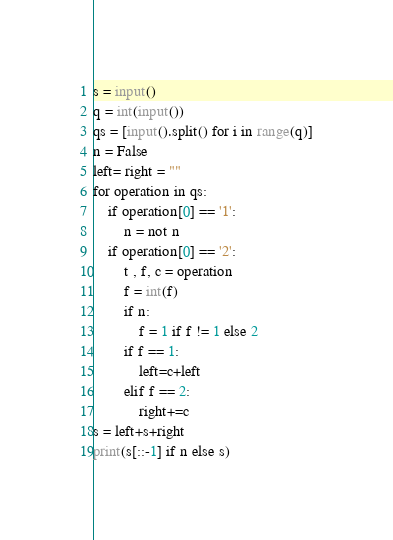Convert code to text. <code><loc_0><loc_0><loc_500><loc_500><_Python_>s = input()
q = int(input())
qs = [input().split() for i in range(q)]
n = False
left= right = ""
for operation in qs:
    if operation[0] == '1':
        n = not n
    if operation[0] == '2':
        t , f, c = operation
        f = int(f)
        if n:
            f = 1 if f != 1 else 2
        if f == 1:
            left=c+left
        elif f == 2:
            right+=c
s = left+s+right
print(s[::-1] if n else s)</code> 